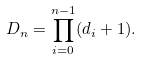<formula> <loc_0><loc_0><loc_500><loc_500>D _ { n } = \prod _ { i = 0 } ^ { n - 1 } ( d _ { i } + 1 ) .</formula> 